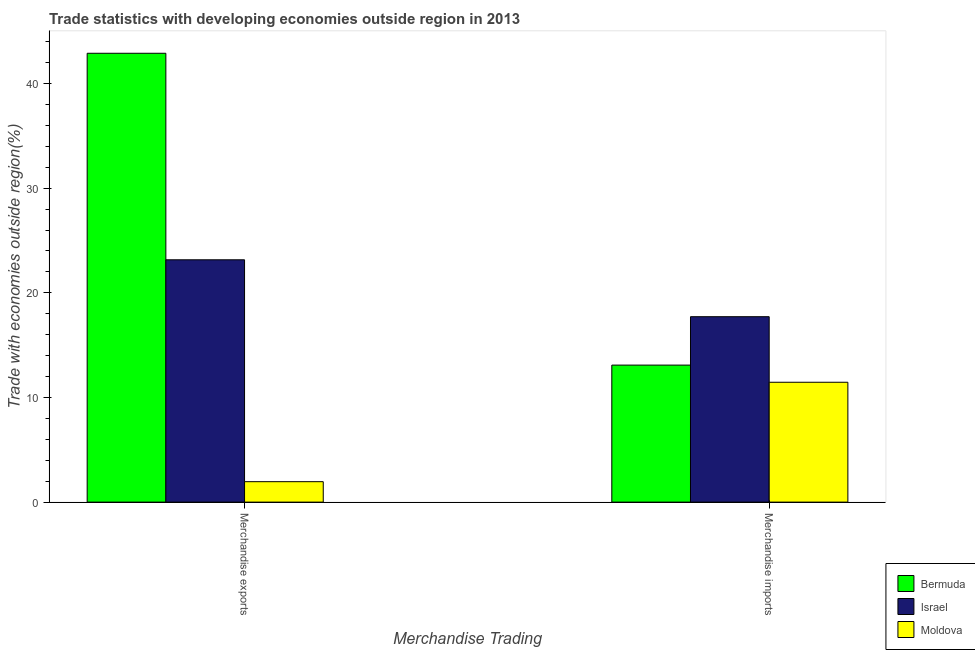How many different coloured bars are there?
Give a very brief answer. 3. How many groups of bars are there?
Keep it short and to the point. 2. Are the number of bars per tick equal to the number of legend labels?
Keep it short and to the point. Yes. How many bars are there on the 1st tick from the left?
Keep it short and to the point. 3. What is the merchandise imports in Bermuda?
Ensure brevity in your answer.  13.09. Across all countries, what is the maximum merchandise imports?
Offer a terse response. 17.72. Across all countries, what is the minimum merchandise exports?
Give a very brief answer. 1.95. In which country was the merchandise exports minimum?
Offer a terse response. Moldova. What is the total merchandise imports in the graph?
Provide a succinct answer. 42.27. What is the difference between the merchandise imports in Bermuda and that in Moldova?
Provide a succinct answer. 1.64. What is the difference between the merchandise imports in Moldova and the merchandise exports in Bermuda?
Offer a very short reply. -31.44. What is the average merchandise imports per country?
Offer a terse response. 14.09. What is the difference between the merchandise exports and merchandise imports in Israel?
Give a very brief answer. 5.44. What is the ratio of the merchandise exports in Bermuda to that in Moldova?
Provide a succinct answer. 21.96. In how many countries, is the merchandise exports greater than the average merchandise exports taken over all countries?
Provide a succinct answer. 2. What does the 1st bar from the right in Merchandise exports represents?
Give a very brief answer. Moldova. How many bars are there?
Your answer should be very brief. 6. How many countries are there in the graph?
Your answer should be compact. 3. What is the difference between two consecutive major ticks on the Y-axis?
Provide a short and direct response. 10. How many legend labels are there?
Your answer should be compact. 3. How are the legend labels stacked?
Ensure brevity in your answer.  Vertical. What is the title of the graph?
Your response must be concise. Trade statistics with developing economies outside region in 2013. Does "OECD members" appear as one of the legend labels in the graph?
Offer a terse response. No. What is the label or title of the X-axis?
Your answer should be very brief. Merchandise Trading. What is the label or title of the Y-axis?
Your answer should be very brief. Trade with economies outside region(%). What is the Trade with economies outside region(%) in Bermuda in Merchandise exports?
Your response must be concise. 42.9. What is the Trade with economies outside region(%) in Israel in Merchandise exports?
Your response must be concise. 23.16. What is the Trade with economies outside region(%) in Moldova in Merchandise exports?
Your answer should be very brief. 1.95. What is the Trade with economies outside region(%) in Bermuda in Merchandise imports?
Keep it short and to the point. 13.09. What is the Trade with economies outside region(%) of Israel in Merchandise imports?
Your answer should be compact. 17.72. What is the Trade with economies outside region(%) in Moldova in Merchandise imports?
Keep it short and to the point. 11.46. Across all Merchandise Trading, what is the maximum Trade with economies outside region(%) of Bermuda?
Your answer should be very brief. 42.9. Across all Merchandise Trading, what is the maximum Trade with economies outside region(%) in Israel?
Your response must be concise. 23.16. Across all Merchandise Trading, what is the maximum Trade with economies outside region(%) of Moldova?
Provide a short and direct response. 11.46. Across all Merchandise Trading, what is the minimum Trade with economies outside region(%) of Bermuda?
Your answer should be compact. 13.09. Across all Merchandise Trading, what is the minimum Trade with economies outside region(%) of Israel?
Provide a succinct answer. 17.72. Across all Merchandise Trading, what is the minimum Trade with economies outside region(%) in Moldova?
Provide a succinct answer. 1.95. What is the total Trade with economies outside region(%) of Bermuda in the graph?
Ensure brevity in your answer.  55.99. What is the total Trade with economies outside region(%) of Israel in the graph?
Keep it short and to the point. 40.88. What is the total Trade with economies outside region(%) in Moldova in the graph?
Offer a terse response. 13.41. What is the difference between the Trade with economies outside region(%) in Bermuda in Merchandise exports and that in Merchandise imports?
Keep it short and to the point. 29.8. What is the difference between the Trade with economies outside region(%) of Israel in Merchandise exports and that in Merchandise imports?
Provide a short and direct response. 5.44. What is the difference between the Trade with economies outside region(%) in Moldova in Merchandise exports and that in Merchandise imports?
Your response must be concise. -9.5. What is the difference between the Trade with economies outside region(%) of Bermuda in Merchandise exports and the Trade with economies outside region(%) of Israel in Merchandise imports?
Make the answer very short. 25.17. What is the difference between the Trade with economies outside region(%) of Bermuda in Merchandise exports and the Trade with economies outside region(%) of Moldova in Merchandise imports?
Your response must be concise. 31.44. What is the difference between the Trade with economies outside region(%) in Israel in Merchandise exports and the Trade with economies outside region(%) in Moldova in Merchandise imports?
Give a very brief answer. 11.7. What is the average Trade with economies outside region(%) of Bermuda per Merchandise Trading?
Ensure brevity in your answer.  28. What is the average Trade with economies outside region(%) of Israel per Merchandise Trading?
Make the answer very short. 20.44. What is the average Trade with economies outside region(%) in Moldova per Merchandise Trading?
Ensure brevity in your answer.  6.7. What is the difference between the Trade with economies outside region(%) in Bermuda and Trade with economies outside region(%) in Israel in Merchandise exports?
Keep it short and to the point. 19.74. What is the difference between the Trade with economies outside region(%) in Bermuda and Trade with economies outside region(%) in Moldova in Merchandise exports?
Provide a succinct answer. 40.94. What is the difference between the Trade with economies outside region(%) of Israel and Trade with economies outside region(%) of Moldova in Merchandise exports?
Your response must be concise. 21.21. What is the difference between the Trade with economies outside region(%) in Bermuda and Trade with economies outside region(%) in Israel in Merchandise imports?
Your response must be concise. -4.63. What is the difference between the Trade with economies outside region(%) in Bermuda and Trade with economies outside region(%) in Moldova in Merchandise imports?
Ensure brevity in your answer.  1.64. What is the difference between the Trade with economies outside region(%) in Israel and Trade with economies outside region(%) in Moldova in Merchandise imports?
Offer a terse response. 6.27. What is the ratio of the Trade with economies outside region(%) in Bermuda in Merchandise exports to that in Merchandise imports?
Your answer should be compact. 3.28. What is the ratio of the Trade with economies outside region(%) of Israel in Merchandise exports to that in Merchandise imports?
Provide a short and direct response. 1.31. What is the ratio of the Trade with economies outside region(%) of Moldova in Merchandise exports to that in Merchandise imports?
Offer a very short reply. 0.17. What is the difference between the highest and the second highest Trade with economies outside region(%) of Bermuda?
Ensure brevity in your answer.  29.8. What is the difference between the highest and the second highest Trade with economies outside region(%) in Israel?
Give a very brief answer. 5.44. What is the difference between the highest and the second highest Trade with economies outside region(%) of Moldova?
Your response must be concise. 9.5. What is the difference between the highest and the lowest Trade with economies outside region(%) in Bermuda?
Your answer should be compact. 29.8. What is the difference between the highest and the lowest Trade with economies outside region(%) in Israel?
Keep it short and to the point. 5.44. What is the difference between the highest and the lowest Trade with economies outside region(%) in Moldova?
Keep it short and to the point. 9.5. 